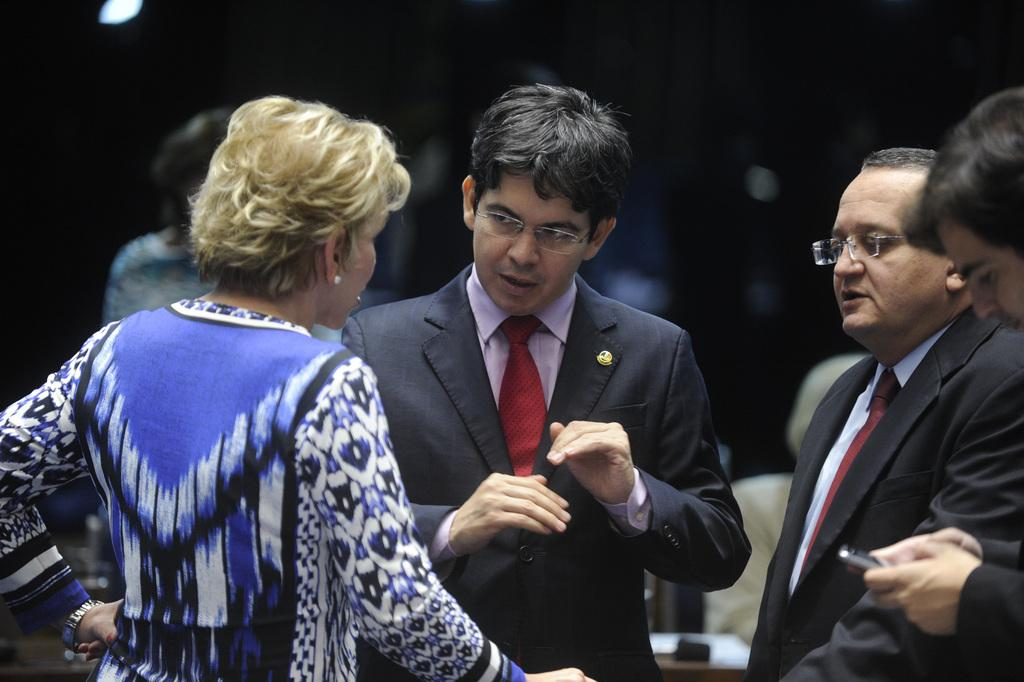How many people are in the image? There is a group of people standing in the image. What is the person on the right side of the image holding? The person is holding a mobile on the right side of the image. What can be observed about the lighting in the image? The background of the image is dark. What type of sticks are being used by the people in the image? There are no sticks visible in the image. Can you describe the truck that is parked in the background of the image? There is no truck present in the image; the background is dark. 